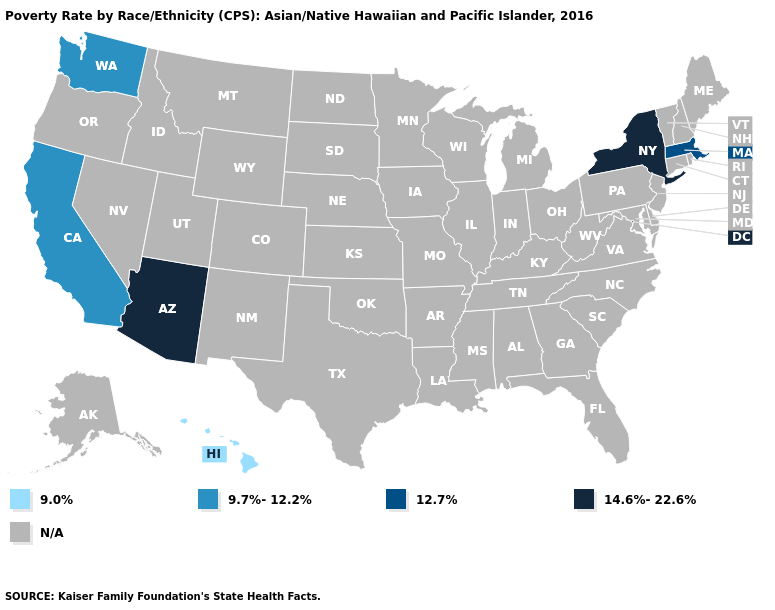Does the map have missing data?
Be succinct. Yes. What is the highest value in the USA?
Be succinct. 14.6%-22.6%. Name the states that have a value in the range 12.7%?
Be succinct. Massachusetts. Does Massachusetts have the highest value in the Northeast?
Answer briefly. No. Does New York have the highest value in the USA?
Be succinct. Yes. Name the states that have a value in the range 9.7%-12.2%?
Keep it brief. California, Washington. What is the value of South Carolina?
Answer briefly. N/A. Name the states that have a value in the range N/A?
Quick response, please. Alabama, Alaska, Arkansas, Colorado, Connecticut, Delaware, Florida, Georgia, Idaho, Illinois, Indiana, Iowa, Kansas, Kentucky, Louisiana, Maine, Maryland, Michigan, Minnesota, Mississippi, Missouri, Montana, Nebraska, Nevada, New Hampshire, New Jersey, New Mexico, North Carolina, North Dakota, Ohio, Oklahoma, Oregon, Pennsylvania, Rhode Island, South Carolina, South Dakota, Tennessee, Texas, Utah, Vermont, Virginia, West Virginia, Wisconsin, Wyoming. Which states have the lowest value in the Northeast?
Write a very short answer. Massachusetts. What is the value of Wisconsin?
Keep it brief. N/A. What is the value of Wisconsin?
Quick response, please. N/A. 